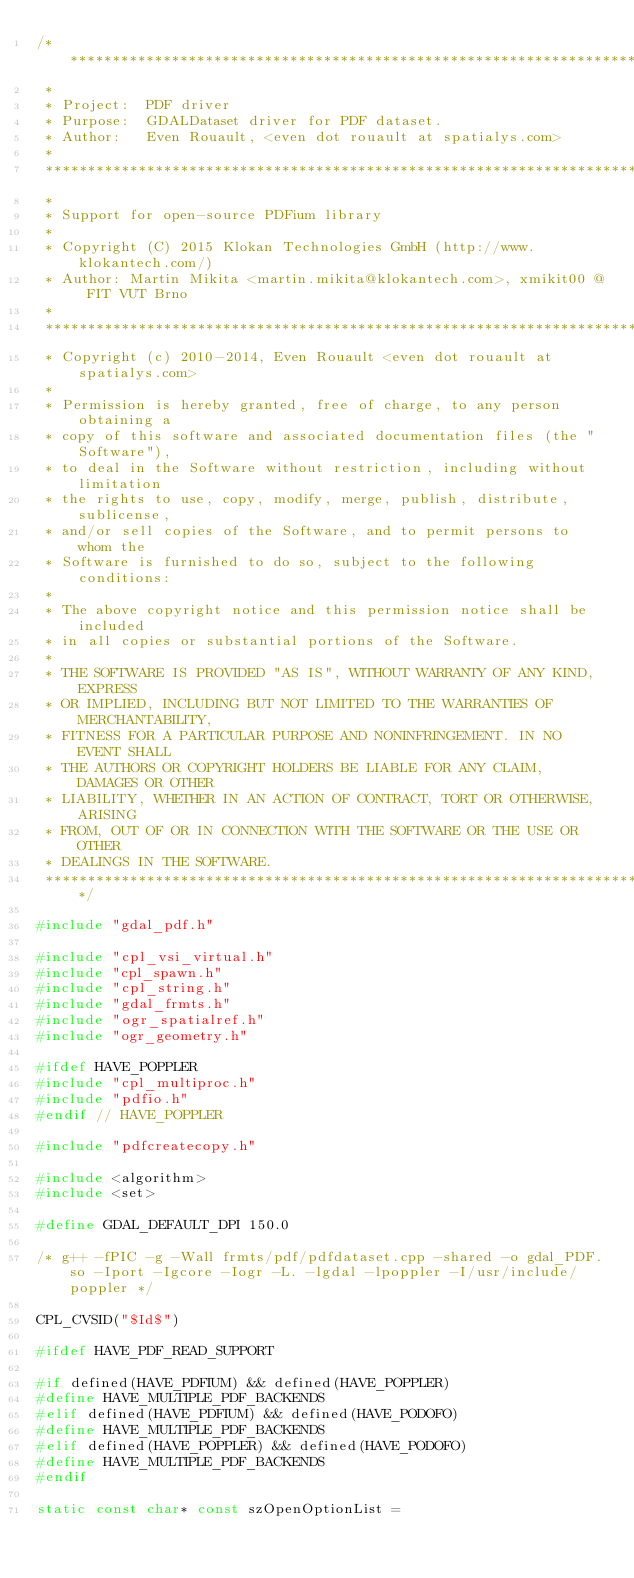Convert code to text. <code><loc_0><loc_0><loc_500><loc_500><_C++_>/******************************************************************************
 *
 * Project:  PDF driver
 * Purpose:  GDALDataset driver for PDF dataset.
 * Author:   Even Rouault, <even dot rouault at spatialys.com>
 *
 ******************************************************************************
 *
 * Support for open-source PDFium library
 *
 * Copyright (C) 2015 Klokan Technologies GmbH (http://www.klokantech.com/)
 * Author: Martin Mikita <martin.mikita@klokantech.com>, xmikit00 @ FIT VUT Brno
 *
 ******************************************************************************
 * Copyright (c) 2010-2014, Even Rouault <even dot rouault at spatialys.com>
 *
 * Permission is hereby granted, free of charge, to any person obtaining a
 * copy of this software and associated documentation files (the "Software"),
 * to deal in the Software without restriction, including without limitation
 * the rights to use, copy, modify, merge, publish, distribute, sublicense,
 * and/or sell copies of the Software, and to permit persons to whom the
 * Software is furnished to do so, subject to the following conditions:
 *
 * The above copyright notice and this permission notice shall be included
 * in all copies or substantial portions of the Software.
 *
 * THE SOFTWARE IS PROVIDED "AS IS", WITHOUT WARRANTY OF ANY KIND, EXPRESS
 * OR IMPLIED, INCLUDING BUT NOT LIMITED TO THE WARRANTIES OF MERCHANTABILITY,
 * FITNESS FOR A PARTICULAR PURPOSE AND NONINFRINGEMENT. IN NO EVENT SHALL
 * THE AUTHORS OR COPYRIGHT HOLDERS BE LIABLE FOR ANY CLAIM, DAMAGES OR OTHER
 * LIABILITY, WHETHER IN AN ACTION OF CONTRACT, TORT OR OTHERWISE, ARISING
 * FROM, OUT OF OR IN CONNECTION WITH THE SOFTWARE OR THE USE OR OTHER
 * DEALINGS IN THE SOFTWARE.
 ****************************************************************************/

#include "gdal_pdf.h"

#include "cpl_vsi_virtual.h"
#include "cpl_spawn.h"
#include "cpl_string.h"
#include "gdal_frmts.h"
#include "ogr_spatialref.h"
#include "ogr_geometry.h"

#ifdef HAVE_POPPLER
#include "cpl_multiproc.h"
#include "pdfio.h"
#endif // HAVE_POPPLER

#include "pdfcreatecopy.h"

#include <algorithm>
#include <set>

#define GDAL_DEFAULT_DPI 150.0

/* g++ -fPIC -g -Wall frmts/pdf/pdfdataset.cpp -shared -o gdal_PDF.so -Iport -Igcore -Iogr -L. -lgdal -lpoppler -I/usr/include/poppler */

CPL_CVSID("$Id$")

#ifdef HAVE_PDF_READ_SUPPORT

#if defined(HAVE_PDFIUM) && defined(HAVE_POPPLER)
#define HAVE_MULTIPLE_PDF_BACKENDS
#elif defined(HAVE_PDFIUM) && defined(HAVE_PODOFO)
#define HAVE_MULTIPLE_PDF_BACKENDS
#elif defined(HAVE_POPPLER) && defined(HAVE_PODOFO)
#define HAVE_MULTIPLE_PDF_BACKENDS
#endif

static const char* const szOpenOptionList =</code> 